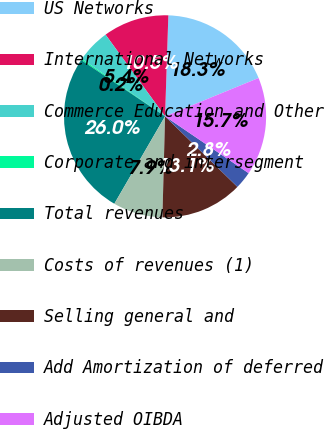<chart> <loc_0><loc_0><loc_500><loc_500><pie_chart><fcel>US Networks<fcel>International Networks<fcel>Commerce Education and Other<fcel>Corporate and intersegment<fcel>Total revenues<fcel>Costs of revenues (1)<fcel>Selling general and<fcel>Add Amortization of deferred<fcel>Adjusted OIBDA<nl><fcel>18.29%<fcel>10.54%<fcel>5.37%<fcel>0.2%<fcel>26.04%<fcel>7.95%<fcel>13.12%<fcel>2.79%<fcel>15.7%<nl></chart> 